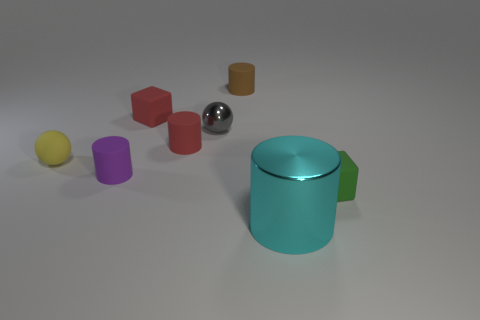Subtract all cyan cylinders. How many cylinders are left? 3 Subtract all purple cylinders. How many cylinders are left? 3 Subtract 2 cylinders. How many cylinders are left? 2 Add 1 small green matte blocks. How many objects exist? 9 Subtract all brown cylinders. Subtract all blue cubes. How many cylinders are left? 3 Subtract all blocks. How many objects are left? 6 Add 7 tiny brown matte objects. How many tiny brown matte objects are left? 8 Add 6 metallic objects. How many metallic objects exist? 8 Subtract 0 green cylinders. How many objects are left? 8 Subtract all large yellow matte spheres. Subtract all small things. How many objects are left? 1 